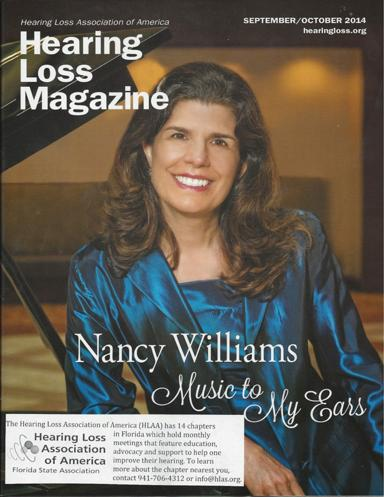What title is given to Nancy Williams in this issue of the magazine? Nancy Williams is titled 'Music to My Ears' in this issue, highlighting her dual passion for music and her advocacy for hearing loss. 